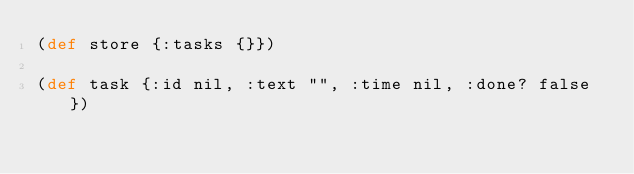<code> <loc_0><loc_0><loc_500><loc_500><_Clojure_>(def store {:tasks {}})

(def task {:id nil, :text "", :time nil, :done? false})
</code> 